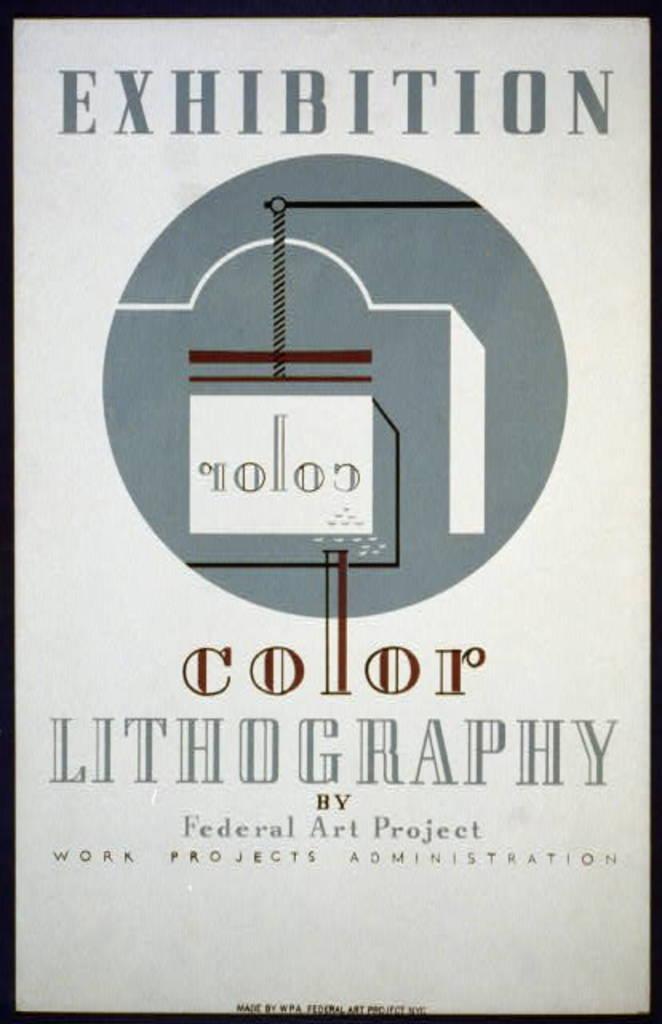Who made this poster?
Your answer should be compact. Federal art project. Who wrote exhibition color lithography?
Offer a terse response. Federal art project. 